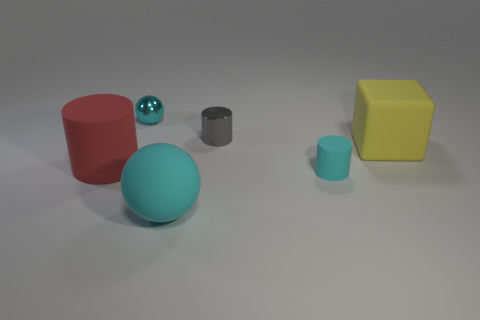What number of tiny shiny objects have the same color as the block?
Your answer should be compact. 0. There is a cyan matte object to the left of the gray metallic cylinder; is there a shiny object that is to the left of it?
Your answer should be very brief. Yes. What number of objects are both to the left of the yellow matte cube and in front of the gray cylinder?
Ensure brevity in your answer.  3. How many big red objects have the same material as the gray cylinder?
Provide a succinct answer. 0. There is a cylinder to the left of the small cylinder left of the small cyan cylinder; what is its size?
Keep it short and to the point. Large. Are there any gray objects of the same shape as the yellow object?
Offer a terse response. No. There is a metallic object left of the tiny gray cylinder; is its size the same as the cyan object that is to the right of the tiny gray thing?
Your response must be concise. Yes. Is the number of yellow matte things behind the yellow block less than the number of cyan objects behind the big red rubber cylinder?
Make the answer very short. Yes. What is the material of the other small sphere that is the same color as the matte sphere?
Offer a very short reply. Metal. What color is the tiny object that is to the right of the tiny gray thing?
Provide a short and direct response. Cyan. 